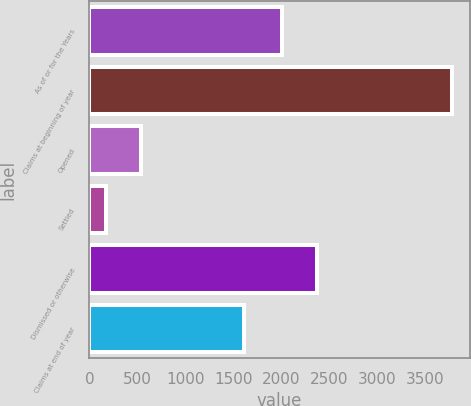Convert chart to OTSL. <chart><loc_0><loc_0><loc_500><loc_500><bar_chart><fcel>As of or for the Years<fcel>Claims at beginning of year<fcel>Opened<fcel>Settled<fcel>Dismissed or otherwise<fcel>Claims at end of year<nl><fcel>2012<fcel>3782<fcel>539.3<fcel>179<fcel>2372.3<fcel>1614<nl></chart> 